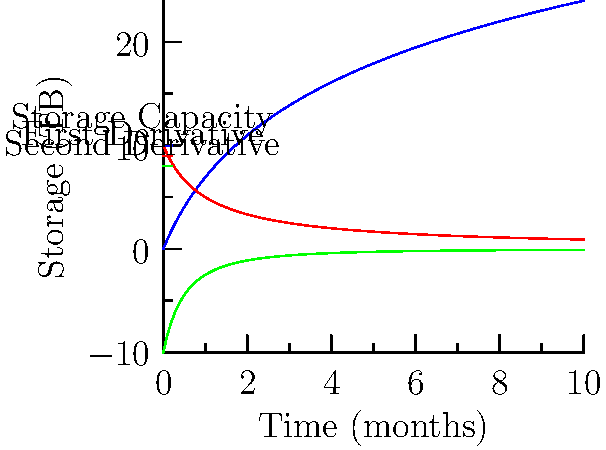As a database administrator, you're analyzing the growth of your data storage capacity over time. The blue curve represents the storage capacity in terabytes (TB) as a function of time in months. The red curve is the first derivative, and the green curve is the second derivative of the storage capacity function. At which point does the rate of change in storage capacity growth start to decrease, and what does this imply for database management? To find the inflection point, we need to follow these steps:

1. Understand the curves:
   - Blue curve: Storage capacity function $f(x)$
   - Red curve: First derivative $f'(x)$
   - Green curve: Second derivative $f''(x)$

2. Identify the inflection point:
   The inflection point occurs where the second derivative $f''(x)$ changes sign, or equivalently, where it crosses the x-axis.

3. Observe the green curve (second derivative):
   It starts negative and approaches zero as x increases, but never crosses the x-axis.

4. Interpret the result:
   There is no true inflection point in this curve. The rate of change (first derivative) is always decreasing, but at a decreasing rate.

5. Find the point of maximum curvature:
   This occurs where the second derivative is closest to zero, which is as x approaches infinity.

6. Practical interpretation:
   The storage capacity growth rate is highest at the beginning and continuously slows down, but never stops completely.

7. Implication for database management:
   - Initial rapid growth requires frequent capacity planning and scaling.
   - Over time, the growth rate stabilizes, allowing for more predictable long-term planning.
   - The database will always require some level of expansion, but the urgency decreases over time.
Answer: No specific inflection point; growth rate always decreases but never becomes negative, implying continuous but slowing storage expansion needs. 